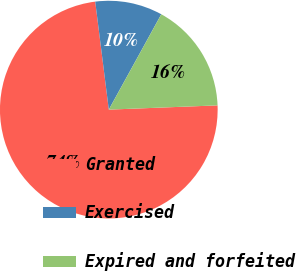<chart> <loc_0><loc_0><loc_500><loc_500><pie_chart><fcel>Granted<fcel>Exercised<fcel>Expired and forfeited<nl><fcel>73.63%<fcel>10.0%<fcel>16.37%<nl></chart> 